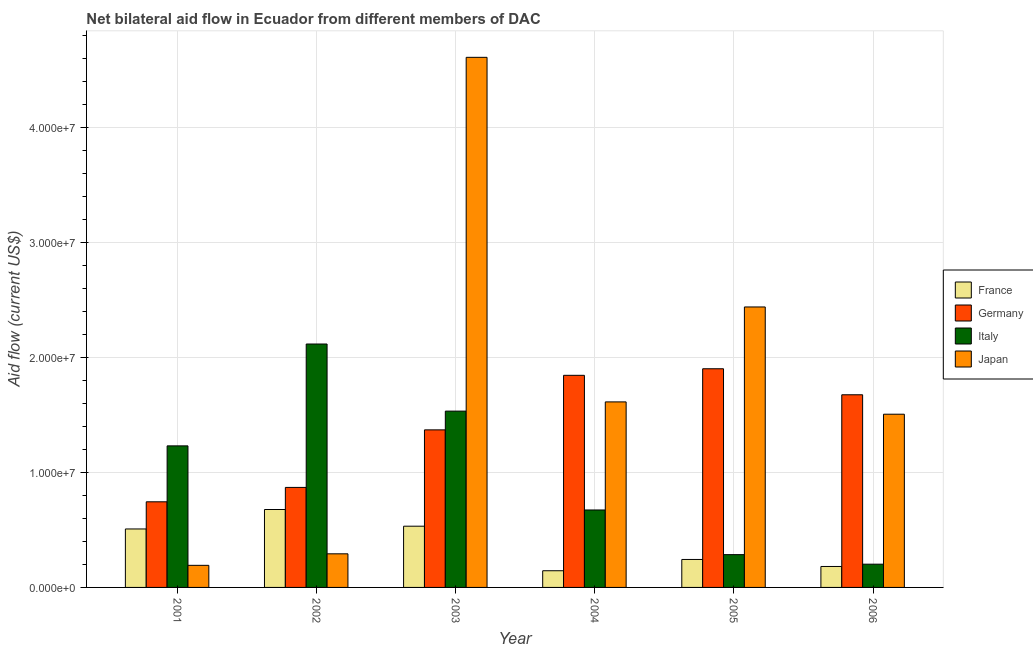How many different coloured bars are there?
Provide a succinct answer. 4. How many groups of bars are there?
Give a very brief answer. 6. Are the number of bars per tick equal to the number of legend labels?
Provide a succinct answer. Yes. Are the number of bars on each tick of the X-axis equal?
Provide a short and direct response. Yes. How many bars are there on the 3rd tick from the left?
Your answer should be compact. 4. How many bars are there on the 2nd tick from the right?
Make the answer very short. 4. What is the label of the 3rd group of bars from the left?
Make the answer very short. 2003. What is the amount of aid given by germany in 2005?
Your response must be concise. 1.90e+07. Across all years, what is the maximum amount of aid given by japan?
Provide a succinct answer. 4.61e+07. Across all years, what is the minimum amount of aid given by germany?
Provide a succinct answer. 7.44e+06. In which year was the amount of aid given by germany maximum?
Provide a short and direct response. 2005. What is the total amount of aid given by germany in the graph?
Offer a very short reply. 8.40e+07. What is the difference between the amount of aid given by france in 2005 and that in 2006?
Give a very brief answer. 6.10e+05. What is the difference between the amount of aid given by germany in 2004 and the amount of aid given by italy in 2006?
Provide a short and direct response. 1.69e+06. What is the average amount of aid given by japan per year?
Your response must be concise. 1.77e+07. In the year 2004, what is the difference between the amount of aid given by france and amount of aid given by italy?
Provide a succinct answer. 0. In how many years, is the amount of aid given by japan greater than 8000000 US$?
Give a very brief answer. 4. What is the ratio of the amount of aid given by germany in 2001 to that in 2005?
Your response must be concise. 0.39. Is the amount of aid given by japan in 2001 less than that in 2003?
Your response must be concise. Yes. Is the difference between the amount of aid given by germany in 2004 and 2006 greater than the difference between the amount of aid given by italy in 2004 and 2006?
Provide a succinct answer. No. What is the difference between the highest and the second highest amount of aid given by france?
Your answer should be compact. 1.45e+06. What is the difference between the highest and the lowest amount of aid given by italy?
Offer a very short reply. 1.91e+07. In how many years, is the amount of aid given by france greater than the average amount of aid given by france taken over all years?
Give a very brief answer. 3. What does the 1st bar from the right in 2001 represents?
Ensure brevity in your answer.  Japan. Is it the case that in every year, the sum of the amount of aid given by france and amount of aid given by germany is greater than the amount of aid given by italy?
Your response must be concise. No. How many bars are there?
Keep it short and to the point. 24. What is the difference between two consecutive major ticks on the Y-axis?
Give a very brief answer. 1.00e+07. Does the graph contain any zero values?
Your answer should be very brief. No. Does the graph contain grids?
Provide a succinct answer. Yes. How are the legend labels stacked?
Provide a succinct answer. Vertical. What is the title of the graph?
Your response must be concise. Net bilateral aid flow in Ecuador from different members of DAC. Does "PFC gas" appear as one of the legend labels in the graph?
Your answer should be compact. No. What is the label or title of the X-axis?
Give a very brief answer. Year. What is the Aid flow (current US$) of France in 2001?
Your answer should be very brief. 5.08e+06. What is the Aid flow (current US$) in Germany in 2001?
Give a very brief answer. 7.44e+06. What is the Aid flow (current US$) of Italy in 2001?
Offer a terse response. 1.23e+07. What is the Aid flow (current US$) in Japan in 2001?
Ensure brevity in your answer.  1.92e+06. What is the Aid flow (current US$) in France in 2002?
Provide a succinct answer. 6.77e+06. What is the Aid flow (current US$) of Germany in 2002?
Your answer should be very brief. 8.69e+06. What is the Aid flow (current US$) in Italy in 2002?
Make the answer very short. 2.12e+07. What is the Aid flow (current US$) of Japan in 2002?
Keep it short and to the point. 2.92e+06. What is the Aid flow (current US$) in France in 2003?
Ensure brevity in your answer.  5.32e+06. What is the Aid flow (current US$) of Germany in 2003?
Provide a succinct answer. 1.37e+07. What is the Aid flow (current US$) in Italy in 2003?
Provide a short and direct response. 1.53e+07. What is the Aid flow (current US$) of Japan in 2003?
Provide a short and direct response. 4.61e+07. What is the Aid flow (current US$) in France in 2004?
Give a very brief answer. 1.45e+06. What is the Aid flow (current US$) in Germany in 2004?
Make the answer very short. 1.84e+07. What is the Aid flow (current US$) in Italy in 2004?
Provide a short and direct response. 6.73e+06. What is the Aid flow (current US$) in Japan in 2004?
Give a very brief answer. 1.61e+07. What is the Aid flow (current US$) in France in 2005?
Make the answer very short. 2.43e+06. What is the Aid flow (current US$) in Germany in 2005?
Ensure brevity in your answer.  1.90e+07. What is the Aid flow (current US$) of Italy in 2005?
Offer a very short reply. 2.85e+06. What is the Aid flow (current US$) of Japan in 2005?
Ensure brevity in your answer.  2.44e+07. What is the Aid flow (current US$) in France in 2006?
Provide a succinct answer. 1.82e+06. What is the Aid flow (current US$) in Germany in 2006?
Give a very brief answer. 1.67e+07. What is the Aid flow (current US$) of Italy in 2006?
Your response must be concise. 2.02e+06. What is the Aid flow (current US$) in Japan in 2006?
Provide a succinct answer. 1.50e+07. Across all years, what is the maximum Aid flow (current US$) of France?
Provide a succinct answer. 6.77e+06. Across all years, what is the maximum Aid flow (current US$) in Germany?
Offer a terse response. 1.90e+07. Across all years, what is the maximum Aid flow (current US$) in Italy?
Give a very brief answer. 2.12e+07. Across all years, what is the maximum Aid flow (current US$) of Japan?
Keep it short and to the point. 4.61e+07. Across all years, what is the minimum Aid flow (current US$) in France?
Your response must be concise. 1.45e+06. Across all years, what is the minimum Aid flow (current US$) in Germany?
Offer a terse response. 7.44e+06. Across all years, what is the minimum Aid flow (current US$) of Italy?
Give a very brief answer. 2.02e+06. Across all years, what is the minimum Aid flow (current US$) of Japan?
Provide a succinct answer. 1.92e+06. What is the total Aid flow (current US$) in France in the graph?
Give a very brief answer. 2.29e+07. What is the total Aid flow (current US$) of Germany in the graph?
Make the answer very short. 8.40e+07. What is the total Aid flow (current US$) of Italy in the graph?
Offer a terse response. 6.04e+07. What is the total Aid flow (current US$) in Japan in the graph?
Ensure brevity in your answer.  1.06e+08. What is the difference between the Aid flow (current US$) of France in 2001 and that in 2002?
Your response must be concise. -1.69e+06. What is the difference between the Aid flow (current US$) of Germany in 2001 and that in 2002?
Give a very brief answer. -1.25e+06. What is the difference between the Aid flow (current US$) in Italy in 2001 and that in 2002?
Ensure brevity in your answer.  -8.85e+06. What is the difference between the Aid flow (current US$) of Germany in 2001 and that in 2003?
Your response must be concise. -6.25e+06. What is the difference between the Aid flow (current US$) of Italy in 2001 and that in 2003?
Your answer should be very brief. -3.02e+06. What is the difference between the Aid flow (current US$) of Japan in 2001 and that in 2003?
Your answer should be very brief. -4.41e+07. What is the difference between the Aid flow (current US$) in France in 2001 and that in 2004?
Keep it short and to the point. 3.63e+06. What is the difference between the Aid flow (current US$) of Germany in 2001 and that in 2004?
Provide a short and direct response. -1.10e+07. What is the difference between the Aid flow (current US$) of Italy in 2001 and that in 2004?
Offer a terse response. 5.57e+06. What is the difference between the Aid flow (current US$) of Japan in 2001 and that in 2004?
Your answer should be compact. -1.42e+07. What is the difference between the Aid flow (current US$) of France in 2001 and that in 2005?
Offer a terse response. 2.65e+06. What is the difference between the Aid flow (current US$) in Germany in 2001 and that in 2005?
Your response must be concise. -1.16e+07. What is the difference between the Aid flow (current US$) in Italy in 2001 and that in 2005?
Keep it short and to the point. 9.45e+06. What is the difference between the Aid flow (current US$) of Japan in 2001 and that in 2005?
Give a very brief answer. -2.24e+07. What is the difference between the Aid flow (current US$) of France in 2001 and that in 2006?
Keep it short and to the point. 3.26e+06. What is the difference between the Aid flow (current US$) in Germany in 2001 and that in 2006?
Make the answer very short. -9.30e+06. What is the difference between the Aid flow (current US$) of Italy in 2001 and that in 2006?
Give a very brief answer. 1.03e+07. What is the difference between the Aid flow (current US$) in Japan in 2001 and that in 2006?
Keep it short and to the point. -1.31e+07. What is the difference between the Aid flow (current US$) in France in 2002 and that in 2003?
Offer a very short reply. 1.45e+06. What is the difference between the Aid flow (current US$) in Germany in 2002 and that in 2003?
Your answer should be compact. -5.00e+06. What is the difference between the Aid flow (current US$) of Italy in 2002 and that in 2003?
Keep it short and to the point. 5.83e+06. What is the difference between the Aid flow (current US$) of Japan in 2002 and that in 2003?
Provide a short and direct response. -4.31e+07. What is the difference between the Aid flow (current US$) in France in 2002 and that in 2004?
Make the answer very short. 5.32e+06. What is the difference between the Aid flow (current US$) of Germany in 2002 and that in 2004?
Offer a very short reply. -9.74e+06. What is the difference between the Aid flow (current US$) in Italy in 2002 and that in 2004?
Your response must be concise. 1.44e+07. What is the difference between the Aid flow (current US$) of Japan in 2002 and that in 2004?
Offer a terse response. -1.32e+07. What is the difference between the Aid flow (current US$) in France in 2002 and that in 2005?
Give a very brief answer. 4.34e+06. What is the difference between the Aid flow (current US$) in Germany in 2002 and that in 2005?
Your answer should be very brief. -1.03e+07. What is the difference between the Aid flow (current US$) in Italy in 2002 and that in 2005?
Your response must be concise. 1.83e+07. What is the difference between the Aid flow (current US$) in Japan in 2002 and that in 2005?
Your answer should be very brief. -2.14e+07. What is the difference between the Aid flow (current US$) in France in 2002 and that in 2006?
Your answer should be very brief. 4.95e+06. What is the difference between the Aid flow (current US$) of Germany in 2002 and that in 2006?
Your answer should be very brief. -8.05e+06. What is the difference between the Aid flow (current US$) in Italy in 2002 and that in 2006?
Your answer should be very brief. 1.91e+07. What is the difference between the Aid flow (current US$) of Japan in 2002 and that in 2006?
Offer a very short reply. -1.21e+07. What is the difference between the Aid flow (current US$) of France in 2003 and that in 2004?
Provide a succinct answer. 3.87e+06. What is the difference between the Aid flow (current US$) in Germany in 2003 and that in 2004?
Your answer should be compact. -4.74e+06. What is the difference between the Aid flow (current US$) in Italy in 2003 and that in 2004?
Ensure brevity in your answer.  8.59e+06. What is the difference between the Aid flow (current US$) of Japan in 2003 and that in 2004?
Provide a short and direct response. 2.99e+07. What is the difference between the Aid flow (current US$) in France in 2003 and that in 2005?
Provide a succinct answer. 2.89e+06. What is the difference between the Aid flow (current US$) in Germany in 2003 and that in 2005?
Offer a very short reply. -5.31e+06. What is the difference between the Aid flow (current US$) in Italy in 2003 and that in 2005?
Your answer should be compact. 1.25e+07. What is the difference between the Aid flow (current US$) of Japan in 2003 and that in 2005?
Keep it short and to the point. 2.17e+07. What is the difference between the Aid flow (current US$) of France in 2003 and that in 2006?
Your answer should be compact. 3.50e+06. What is the difference between the Aid flow (current US$) of Germany in 2003 and that in 2006?
Make the answer very short. -3.05e+06. What is the difference between the Aid flow (current US$) in Italy in 2003 and that in 2006?
Provide a succinct answer. 1.33e+07. What is the difference between the Aid flow (current US$) of Japan in 2003 and that in 2006?
Give a very brief answer. 3.10e+07. What is the difference between the Aid flow (current US$) in France in 2004 and that in 2005?
Offer a terse response. -9.80e+05. What is the difference between the Aid flow (current US$) of Germany in 2004 and that in 2005?
Provide a succinct answer. -5.70e+05. What is the difference between the Aid flow (current US$) in Italy in 2004 and that in 2005?
Provide a short and direct response. 3.88e+06. What is the difference between the Aid flow (current US$) of Japan in 2004 and that in 2005?
Ensure brevity in your answer.  -8.25e+06. What is the difference between the Aid flow (current US$) in France in 2004 and that in 2006?
Keep it short and to the point. -3.70e+05. What is the difference between the Aid flow (current US$) of Germany in 2004 and that in 2006?
Ensure brevity in your answer.  1.69e+06. What is the difference between the Aid flow (current US$) in Italy in 2004 and that in 2006?
Provide a short and direct response. 4.71e+06. What is the difference between the Aid flow (current US$) of Japan in 2004 and that in 2006?
Give a very brief answer. 1.07e+06. What is the difference between the Aid flow (current US$) in France in 2005 and that in 2006?
Keep it short and to the point. 6.10e+05. What is the difference between the Aid flow (current US$) in Germany in 2005 and that in 2006?
Your answer should be compact. 2.26e+06. What is the difference between the Aid flow (current US$) of Italy in 2005 and that in 2006?
Make the answer very short. 8.30e+05. What is the difference between the Aid flow (current US$) in Japan in 2005 and that in 2006?
Make the answer very short. 9.32e+06. What is the difference between the Aid flow (current US$) of France in 2001 and the Aid flow (current US$) of Germany in 2002?
Ensure brevity in your answer.  -3.61e+06. What is the difference between the Aid flow (current US$) of France in 2001 and the Aid flow (current US$) of Italy in 2002?
Provide a succinct answer. -1.61e+07. What is the difference between the Aid flow (current US$) of France in 2001 and the Aid flow (current US$) of Japan in 2002?
Your answer should be very brief. 2.16e+06. What is the difference between the Aid flow (current US$) in Germany in 2001 and the Aid flow (current US$) in Italy in 2002?
Make the answer very short. -1.37e+07. What is the difference between the Aid flow (current US$) in Germany in 2001 and the Aid flow (current US$) in Japan in 2002?
Your answer should be very brief. 4.52e+06. What is the difference between the Aid flow (current US$) of Italy in 2001 and the Aid flow (current US$) of Japan in 2002?
Offer a very short reply. 9.38e+06. What is the difference between the Aid flow (current US$) of France in 2001 and the Aid flow (current US$) of Germany in 2003?
Keep it short and to the point. -8.61e+06. What is the difference between the Aid flow (current US$) of France in 2001 and the Aid flow (current US$) of Italy in 2003?
Make the answer very short. -1.02e+07. What is the difference between the Aid flow (current US$) of France in 2001 and the Aid flow (current US$) of Japan in 2003?
Provide a succinct answer. -4.10e+07. What is the difference between the Aid flow (current US$) in Germany in 2001 and the Aid flow (current US$) in Italy in 2003?
Keep it short and to the point. -7.88e+06. What is the difference between the Aid flow (current US$) of Germany in 2001 and the Aid flow (current US$) of Japan in 2003?
Keep it short and to the point. -3.86e+07. What is the difference between the Aid flow (current US$) of Italy in 2001 and the Aid flow (current US$) of Japan in 2003?
Provide a short and direct response. -3.38e+07. What is the difference between the Aid flow (current US$) of France in 2001 and the Aid flow (current US$) of Germany in 2004?
Your response must be concise. -1.34e+07. What is the difference between the Aid flow (current US$) in France in 2001 and the Aid flow (current US$) in Italy in 2004?
Give a very brief answer. -1.65e+06. What is the difference between the Aid flow (current US$) of France in 2001 and the Aid flow (current US$) of Japan in 2004?
Make the answer very short. -1.10e+07. What is the difference between the Aid flow (current US$) in Germany in 2001 and the Aid flow (current US$) in Italy in 2004?
Your response must be concise. 7.10e+05. What is the difference between the Aid flow (current US$) of Germany in 2001 and the Aid flow (current US$) of Japan in 2004?
Keep it short and to the point. -8.68e+06. What is the difference between the Aid flow (current US$) in Italy in 2001 and the Aid flow (current US$) in Japan in 2004?
Give a very brief answer. -3.82e+06. What is the difference between the Aid flow (current US$) of France in 2001 and the Aid flow (current US$) of Germany in 2005?
Offer a terse response. -1.39e+07. What is the difference between the Aid flow (current US$) in France in 2001 and the Aid flow (current US$) in Italy in 2005?
Your response must be concise. 2.23e+06. What is the difference between the Aid flow (current US$) in France in 2001 and the Aid flow (current US$) in Japan in 2005?
Your answer should be compact. -1.93e+07. What is the difference between the Aid flow (current US$) of Germany in 2001 and the Aid flow (current US$) of Italy in 2005?
Give a very brief answer. 4.59e+06. What is the difference between the Aid flow (current US$) of Germany in 2001 and the Aid flow (current US$) of Japan in 2005?
Offer a terse response. -1.69e+07. What is the difference between the Aid flow (current US$) of Italy in 2001 and the Aid flow (current US$) of Japan in 2005?
Provide a succinct answer. -1.21e+07. What is the difference between the Aid flow (current US$) in France in 2001 and the Aid flow (current US$) in Germany in 2006?
Your answer should be very brief. -1.17e+07. What is the difference between the Aid flow (current US$) of France in 2001 and the Aid flow (current US$) of Italy in 2006?
Provide a short and direct response. 3.06e+06. What is the difference between the Aid flow (current US$) in France in 2001 and the Aid flow (current US$) in Japan in 2006?
Make the answer very short. -9.97e+06. What is the difference between the Aid flow (current US$) of Germany in 2001 and the Aid flow (current US$) of Italy in 2006?
Your answer should be very brief. 5.42e+06. What is the difference between the Aid flow (current US$) in Germany in 2001 and the Aid flow (current US$) in Japan in 2006?
Keep it short and to the point. -7.61e+06. What is the difference between the Aid flow (current US$) of Italy in 2001 and the Aid flow (current US$) of Japan in 2006?
Ensure brevity in your answer.  -2.75e+06. What is the difference between the Aid flow (current US$) of France in 2002 and the Aid flow (current US$) of Germany in 2003?
Offer a very short reply. -6.92e+06. What is the difference between the Aid flow (current US$) of France in 2002 and the Aid flow (current US$) of Italy in 2003?
Offer a terse response. -8.55e+06. What is the difference between the Aid flow (current US$) of France in 2002 and the Aid flow (current US$) of Japan in 2003?
Give a very brief answer. -3.93e+07. What is the difference between the Aid flow (current US$) in Germany in 2002 and the Aid flow (current US$) in Italy in 2003?
Your answer should be compact. -6.63e+06. What is the difference between the Aid flow (current US$) in Germany in 2002 and the Aid flow (current US$) in Japan in 2003?
Ensure brevity in your answer.  -3.74e+07. What is the difference between the Aid flow (current US$) of Italy in 2002 and the Aid flow (current US$) of Japan in 2003?
Make the answer very short. -2.49e+07. What is the difference between the Aid flow (current US$) of France in 2002 and the Aid flow (current US$) of Germany in 2004?
Your response must be concise. -1.17e+07. What is the difference between the Aid flow (current US$) of France in 2002 and the Aid flow (current US$) of Japan in 2004?
Offer a very short reply. -9.35e+06. What is the difference between the Aid flow (current US$) in Germany in 2002 and the Aid flow (current US$) in Italy in 2004?
Make the answer very short. 1.96e+06. What is the difference between the Aid flow (current US$) in Germany in 2002 and the Aid flow (current US$) in Japan in 2004?
Your answer should be compact. -7.43e+06. What is the difference between the Aid flow (current US$) in Italy in 2002 and the Aid flow (current US$) in Japan in 2004?
Offer a terse response. 5.03e+06. What is the difference between the Aid flow (current US$) in France in 2002 and the Aid flow (current US$) in Germany in 2005?
Offer a terse response. -1.22e+07. What is the difference between the Aid flow (current US$) of France in 2002 and the Aid flow (current US$) of Italy in 2005?
Ensure brevity in your answer.  3.92e+06. What is the difference between the Aid flow (current US$) of France in 2002 and the Aid flow (current US$) of Japan in 2005?
Your answer should be very brief. -1.76e+07. What is the difference between the Aid flow (current US$) in Germany in 2002 and the Aid flow (current US$) in Italy in 2005?
Provide a short and direct response. 5.84e+06. What is the difference between the Aid flow (current US$) in Germany in 2002 and the Aid flow (current US$) in Japan in 2005?
Provide a short and direct response. -1.57e+07. What is the difference between the Aid flow (current US$) of Italy in 2002 and the Aid flow (current US$) of Japan in 2005?
Your response must be concise. -3.22e+06. What is the difference between the Aid flow (current US$) in France in 2002 and the Aid flow (current US$) in Germany in 2006?
Your answer should be very brief. -9.97e+06. What is the difference between the Aid flow (current US$) in France in 2002 and the Aid flow (current US$) in Italy in 2006?
Your answer should be compact. 4.75e+06. What is the difference between the Aid flow (current US$) of France in 2002 and the Aid flow (current US$) of Japan in 2006?
Provide a succinct answer. -8.28e+06. What is the difference between the Aid flow (current US$) of Germany in 2002 and the Aid flow (current US$) of Italy in 2006?
Offer a very short reply. 6.67e+06. What is the difference between the Aid flow (current US$) in Germany in 2002 and the Aid flow (current US$) in Japan in 2006?
Your answer should be very brief. -6.36e+06. What is the difference between the Aid flow (current US$) in Italy in 2002 and the Aid flow (current US$) in Japan in 2006?
Your answer should be compact. 6.10e+06. What is the difference between the Aid flow (current US$) of France in 2003 and the Aid flow (current US$) of Germany in 2004?
Your response must be concise. -1.31e+07. What is the difference between the Aid flow (current US$) of France in 2003 and the Aid flow (current US$) of Italy in 2004?
Offer a very short reply. -1.41e+06. What is the difference between the Aid flow (current US$) in France in 2003 and the Aid flow (current US$) in Japan in 2004?
Offer a very short reply. -1.08e+07. What is the difference between the Aid flow (current US$) in Germany in 2003 and the Aid flow (current US$) in Italy in 2004?
Your answer should be compact. 6.96e+06. What is the difference between the Aid flow (current US$) of Germany in 2003 and the Aid flow (current US$) of Japan in 2004?
Offer a terse response. -2.43e+06. What is the difference between the Aid flow (current US$) of Italy in 2003 and the Aid flow (current US$) of Japan in 2004?
Your answer should be compact. -8.00e+05. What is the difference between the Aid flow (current US$) in France in 2003 and the Aid flow (current US$) in Germany in 2005?
Make the answer very short. -1.37e+07. What is the difference between the Aid flow (current US$) in France in 2003 and the Aid flow (current US$) in Italy in 2005?
Provide a short and direct response. 2.47e+06. What is the difference between the Aid flow (current US$) in France in 2003 and the Aid flow (current US$) in Japan in 2005?
Your response must be concise. -1.90e+07. What is the difference between the Aid flow (current US$) of Germany in 2003 and the Aid flow (current US$) of Italy in 2005?
Offer a terse response. 1.08e+07. What is the difference between the Aid flow (current US$) in Germany in 2003 and the Aid flow (current US$) in Japan in 2005?
Your answer should be compact. -1.07e+07. What is the difference between the Aid flow (current US$) in Italy in 2003 and the Aid flow (current US$) in Japan in 2005?
Make the answer very short. -9.05e+06. What is the difference between the Aid flow (current US$) of France in 2003 and the Aid flow (current US$) of Germany in 2006?
Your answer should be compact. -1.14e+07. What is the difference between the Aid flow (current US$) in France in 2003 and the Aid flow (current US$) in Italy in 2006?
Give a very brief answer. 3.30e+06. What is the difference between the Aid flow (current US$) of France in 2003 and the Aid flow (current US$) of Japan in 2006?
Make the answer very short. -9.73e+06. What is the difference between the Aid flow (current US$) in Germany in 2003 and the Aid flow (current US$) in Italy in 2006?
Offer a terse response. 1.17e+07. What is the difference between the Aid flow (current US$) in Germany in 2003 and the Aid flow (current US$) in Japan in 2006?
Your answer should be very brief. -1.36e+06. What is the difference between the Aid flow (current US$) in France in 2004 and the Aid flow (current US$) in Germany in 2005?
Offer a very short reply. -1.76e+07. What is the difference between the Aid flow (current US$) of France in 2004 and the Aid flow (current US$) of Italy in 2005?
Give a very brief answer. -1.40e+06. What is the difference between the Aid flow (current US$) in France in 2004 and the Aid flow (current US$) in Japan in 2005?
Your answer should be compact. -2.29e+07. What is the difference between the Aid flow (current US$) in Germany in 2004 and the Aid flow (current US$) in Italy in 2005?
Your answer should be very brief. 1.56e+07. What is the difference between the Aid flow (current US$) of Germany in 2004 and the Aid flow (current US$) of Japan in 2005?
Make the answer very short. -5.94e+06. What is the difference between the Aid flow (current US$) in Italy in 2004 and the Aid flow (current US$) in Japan in 2005?
Provide a succinct answer. -1.76e+07. What is the difference between the Aid flow (current US$) in France in 2004 and the Aid flow (current US$) in Germany in 2006?
Offer a terse response. -1.53e+07. What is the difference between the Aid flow (current US$) of France in 2004 and the Aid flow (current US$) of Italy in 2006?
Give a very brief answer. -5.70e+05. What is the difference between the Aid flow (current US$) of France in 2004 and the Aid flow (current US$) of Japan in 2006?
Keep it short and to the point. -1.36e+07. What is the difference between the Aid flow (current US$) in Germany in 2004 and the Aid flow (current US$) in Italy in 2006?
Keep it short and to the point. 1.64e+07. What is the difference between the Aid flow (current US$) of Germany in 2004 and the Aid flow (current US$) of Japan in 2006?
Your response must be concise. 3.38e+06. What is the difference between the Aid flow (current US$) in Italy in 2004 and the Aid flow (current US$) in Japan in 2006?
Give a very brief answer. -8.32e+06. What is the difference between the Aid flow (current US$) in France in 2005 and the Aid flow (current US$) in Germany in 2006?
Your response must be concise. -1.43e+07. What is the difference between the Aid flow (current US$) in France in 2005 and the Aid flow (current US$) in Japan in 2006?
Make the answer very short. -1.26e+07. What is the difference between the Aid flow (current US$) of Germany in 2005 and the Aid flow (current US$) of Italy in 2006?
Your response must be concise. 1.70e+07. What is the difference between the Aid flow (current US$) of Germany in 2005 and the Aid flow (current US$) of Japan in 2006?
Your answer should be very brief. 3.95e+06. What is the difference between the Aid flow (current US$) of Italy in 2005 and the Aid flow (current US$) of Japan in 2006?
Offer a very short reply. -1.22e+07. What is the average Aid flow (current US$) in France per year?
Keep it short and to the point. 3.81e+06. What is the average Aid flow (current US$) in Germany per year?
Provide a succinct answer. 1.40e+07. What is the average Aid flow (current US$) in Italy per year?
Keep it short and to the point. 1.01e+07. What is the average Aid flow (current US$) of Japan per year?
Keep it short and to the point. 1.77e+07. In the year 2001, what is the difference between the Aid flow (current US$) in France and Aid flow (current US$) in Germany?
Your answer should be compact. -2.36e+06. In the year 2001, what is the difference between the Aid flow (current US$) of France and Aid flow (current US$) of Italy?
Ensure brevity in your answer.  -7.22e+06. In the year 2001, what is the difference between the Aid flow (current US$) in France and Aid flow (current US$) in Japan?
Offer a terse response. 3.16e+06. In the year 2001, what is the difference between the Aid flow (current US$) in Germany and Aid flow (current US$) in Italy?
Provide a succinct answer. -4.86e+06. In the year 2001, what is the difference between the Aid flow (current US$) of Germany and Aid flow (current US$) of Japan?
Your response must be concise. 5.52e+06. In the year 2001, what is the difference between the Aid flow (current US$) in Italy and Aid flow (current US$) in Japan?
Make the answer very short. 1.04e+07. In the year 2002, what is the difference between the Aid flow (current US$) in France and Aid flow (current US$) in Germany?
Your answer should be very brief. -1.92e+06. In the year 2002, what is the difference between the Aid flow (current US$) in France and Aid flow (current US$) in Italy?
Provide a short and direct response. -1.44e+07. In the year 2002, what is the difference between the Aid flow (current US$) of France and Aid flow (current US$) of Japan?
Give a very brief answer. 3.85e+06. In the year 2002, what is the difference between the Aid flow (current US$) in Germany and Aid flow (current US$) in Italy?
Your answer should be very brief. -1.25e+07. In the year 2002, what is the difference between the Aid flow (current US$) of Germany and Aid flow (current US$) of Japan?
Give a very brief answer. 5.77e+06. In the year 2002, what is the difference between the Aid flow (current US$) in Italy and Aid flow (current US$) in Japan?
Your response must be concise. 1.82e+07. In the year 2003, what is the difference between the Aid flow (current US$) of France and Aid flow (current US$) of Germany?
Provide a succinct answer. -8.37e+06. In the year 2003, what is the difference between the Aid flow (current US$) in France and Aid flow (current US$) in Italy?
Give a very brief answer. -1.00e+07. In the year 2003, what is the difference between the Aid flow (current US$) of France and Aid flow (current US$) of Japan?
Give a very brief answer. -4.07e+07. In the year 2003, what is the difference between the Aid flow (current US$) in Germany and Aid flow (current US$) in Italy?
Your answer should be very brief. -1.63e+06. In the year 2003, what is the difference between the Aid flow (current US$) in Germany and Aid flow (current US$) in Japan?
Provide a short and direct response. -3.24e+07. In the year 2003, what is the difference between the Aid flow (current US$) in Italy and Aid flow (current US$) in Japan?
Your response must be concise. -3.07e+07. In the year 2004, what is the difference between the Aid flow (current US$) in France and Aid flow (current US$) in Germany?
Ensure brevity in your answer.  -1.70e+07. In the year 2004, what is the difference between the Aid flow (current US$) in France and Aid flow (current US$) in Italy?
Offer a very short reply. -5.28e+06. In the year 2004, what is the difference between the Aid flow (current US$) in France and Aid flow (current US$) in Japan?
Make the answer very short. -1.47e+07. In the year 2004, what is the difference between the Aid flow (current US$) in Germany and Aid flow (current US$) in Italy?
Provide a succinct answer. 1.17e+07. In the year 2004, what is the difference between the Aid flow (current US$) in Germany and Aid flow (current US$) in Japan?
Make the answer very short. 2.31e+06. In the year 2004, what is the difference between the Aid flow (current US$) in Italy and Aid flow (current US$) in Japan?
Provide a succinct answer. -9.39e+06. In the year 2005, what is the difference between the Aid flow (current US$) in France and Aid flow (current US$) in Germany?
Your response must be concise. -1.66e+07. In the year 2005, what is the difference between the Aid flow (current US$) of France and Aid flow (current US$) of Italy?
Your answer should be compact. -4.20e+05. In the year 2005, what is the difference between the Aid flow (current US$) of France and Aid flow (current US$) of Japan?
Your answer should be very brief. -2.19e+07. In the year 2005, what is the difference between the Aid flow (current US$) of Germany and Aid flow (current US$) of Italy?
Give a very brief answer. 1.62e+07. In the year 2005, what is the difference between the Aid flow (current US$) in Germany and Aid flow (current US$) in Japan?
Offer a terse response. -5.37e+06. In the year 2005, what is the difference between the Aid flow (current US$) in Italy and Aid flow (current US$) in Japan?
Your response must be concise. -2.15e+07. In the year 2006, what is the difference between the Aid flow (current US$) of France and Aid flow (current US$) of Germany?
Your answer should be compact. -1.49e+07. In the year 2006, what is the difference between the Aid flow (current US$) in France and Aid flow (current US$) in Japan?
Offer a very short reply. -1.32e+07. In the year 2006, what is the difference between the Aid flow (current US$) of Germany and Aid flow (current US$) of Italy?
Give a very brief answer. 1.47e+07. In the year 2006, what is the difference between the Aid flow (current US$) in Germany and Aid flow (current US$) in Japan?
Ensure brevity in your answer.  1.69e+06. In the year 2006, what is the difference between the Aid flow (current US$) of Italy and Aid flow (current US$) of Japan?
Provide a short and direct response. -1.30e+07. What is the ratio of the Aid flow (current US$) in France in 2001 to that in 2002?
Provide a short and direct response. 0.75. What is the ratio of the Aid flow (current US$) in Germany in 2001 to that in 2002?
Offer a terse response. 0.86. What is the ratio of the Aid flow (current US$) of Italy in 2001 to that in 2002?
Your response must be concise. 0.58. What is the ratio of the Aid flow (current US$) in Japan in 2001 to that in 2002?
Your response must be concise. 0.66. What is the ratio of the Aid flow (current US$) in France in 2001 to that in 2003?
Offer a very short reply. 0.95. What is the ratio of the Aid flow (current US$) in Germany in 2001 to that in 2003?
Keep it short and to the point. 0.54. What is the ratio of the Aid flow (current US$) of Italy in 2001 to that in 2003?
Keep it short and to the point. 0.8. What is the ratio of the Aid flow (current US$) in Japan in 2001 to that in 2003?
Your answer should be very brief. 0.04. What is the ratio of the Aid flow (current US$) of France in 2001 to that in 2004?
Keep it short and to the point. 3.5. What is the ratio of the Aid flow (current US$) in Germany in 2001 to that in 2004?
Keep it short and to the point. 0.4. What is the ratio of the Aid flow (current US$) of Italy in 2001 to that in 2004?
Your answer should be compact. 1.83. What is the ratio of the Aid flow (current US$) of Japan in 2001 to that in 2004?
Your answer should be compact. 0.12. What is the ratio of the Aid flow (current US$) in France in 2001 to that in 2005?
Offer a terse response. 2.09. What is the ratio of the Aid flow (current US$) in Germany in 2001 to that in 2005?
Provide a short and direct response. 0.39. What is the ratio of the Aid flow (current US$) of Italy in 2001 to that in 2005?
Provide a short and direct response. 4.32. What is the ratio of the Aid flow (current US$) in Japan in 2001 to that in 2005?
Provide a succinct answer. 0.08. What is the ratio of the Aid flow (current US$) in France in 2001 to that in 2006?
Ensure brevity in your answer.  2.79. What is the ratio of the Aid flow (current US$) of Germany in 2001 to that in 2006?
Your answer should be compact. 0.44. What is the ratio of the Aid flow (current US$) of Italy in 2001 to that in 2006?
Ensure brevity in your answer.  6.09. What is the ratio of the Aid flow (current US$) of Japan in 2001 to that in 2006?
Offer a very short reply. 0.13. What is the ratio of the Aid flow (current US$) in France in 2002 to that in 2003?
Offer a very short reply. 1.27. What is the ratio of the Aid flow (current US$) of Germany in 2002 to that in 2003?
Offer a terse response. 0.63. What is the ratio of the Aid flow (current US$) of Italy in 2002 to that in 2003?
Make the answer very short. 1.38. What is the ratio of the Aid flow (current US$) in Japan in 2002 to that in 2003?
Your answer should be compact. 0.06. What is the ratio of the Aid flow (current US$) of France in 2002 to that in 2004?
Your answer should be compact. 4.67. What is the ratio of the Aid flow (current US$) of Germany in 2002 to that in 2004?
Your answer should be very brief. 0.47. What is the ratio of the Aid flow (current US$) of Italy in 2002 to that in 2004?
Your answer should be very brief. 3.14. What is the ratio of the Aid flow (current US$) in Japan in 2002 to that in 2004?
Ensure brevity in your answer.  0.18. What is the ratio of the Aid flow (current US$) in France in 2002 to that in 2005?
Offer a terse response. 2.79. What is the ratio of the Aid flow (current US$) of Germany in 2002 to that in 2005?
Your answer should be very brief. 0.46. What is the ratio of the Aid flow (current US$) in Italy in 2002 to that in 2005?
Your answer should be compact. 7.42. What is the ratio of the Aid flow (current US$) in Japan in 2002 to that in 2005?
Your response must be concise. 0.12. What is the ratio of the Aid flow (current US$) in France in 2002 to that in 2006?
Your answer should be very brief. 3.72. What is the ratio of the Aid flow (current US$) in Germany in 2002 to that in 2006?
Keep it short and to the point. 0.52. What is the ratio of the Aid flow (current US$) of Italy in 2002 to that in 2006?
Provide a succinct answer. 10.47. What is the ratio of the Aid flow (current US$) of Japan in 2002 to that in 2006?
Your answer should be very brief. 0.19. What is the ratio of the Aid flow (current US$) of France in 2003 to that in 2004?
Ensure brevity in your answer.  3.67. What is the ratio of the Aid flow (current US$) of Germany in 2003 to that in 2004?
Keep it short and to the point. 0.74. What is the ratio of the Aid flow (current US$) of Italy in 2003 to that in 2004?
Provide a short and direct response. 2.28. What is the ratio of the Aid flow (current US$) of Japan in 2003 to that in 2004?
Offer a terse response. 2.86. What is the ratio of the Aid flow (current US$) in France in 2003 to that in 2005?
Offer a terse response. 2.19. What is the ratio of the Aid flow (current US$) of Germany in 2003 to that in 2005?
Provide a short and direct response. 0.72. What is the ratio of the Aid flow (current US$) in Italy in 2003 to that in 2005?
Offer a terse response. 5.38. What is the ratio of the Aid flow (current US$) in Japan in 2003 to that in 2005?
Provide a succinct answer. 1.89. What is the ratio of the Aid flow (current US$) in France in 2003 to that in 2006?
Your response must be concise. 2.92. What is the ratio of the Aid flow (current US$) of Germany in 2003 to that in 2006?
Your answer should be very brief. 0.82. What is the ratio of the Aid flow (current US$) in Italy in 2003 to that in 2006?
Keep it short and to the point. 7.58. What is the ratio of the Aid flow (current US$) of Japan in 2003 to that in 2006?
Provide a short and direct response. 3.06. What is the ratio of the Aid flow (current US$) of France in 2004 to that in 2005?
Offer a terse response. 0.6. What is the ratio of the Aid flow (current US$) of Germany in 2004 to that in 2005?
Your answer should be compact. 0.97. What is the ratio of the Aid flow (current US$) in Italy in 2004 to that in 2005?
Provide a succinct answer. 2.36. What is the ratio of the Aid flow (current US$) in Japan in 2004 to that in 2005?
Your answer should be very brief. 0.66. What is the ratio of the Aid flow (current US$) of France in 2004 to that in 2006?
Your answer should be very brief. 0.8. What is the ratio of the Aid flow (current US$) in Germany in 2004 to that in 2006?
Your answer should be compact. 1.1. What is the ratio of the Aid flow (current US$) of Italy in 2004 to that in 2006?
Provide a short and direct response. 3.33. What is the ratio of the Aid flow (current US$) of Japan in 2004 to that in 2006?
Your answer should be very brief. 1.07. What is the ratio of the Aid flow (current US$) in France in 2005 to that in 2006?
Your response must be concise. 1.34. What is the ratio of the Aid flow (current US$) in Germany in 2005 to that in 2006?
Offer a very short reply. 1.14. What is the ratio of the Aid flow (current US$) in Italy in 2005 to that in 2006?
Offer a very short reply. 1.41. What is the ratio of the Aid flow (current US$) of Japan in 2005 to that in 2006?
Your response must be concise. 1.62. What is the difference between the highest and the second highest Aid flow (current US$) of France?
Make the answer very short. 1.45e+06. What is the difference between the highest and the second highest Aid flow (current US$) of Germany?
Give a very brief answer. 5.70e+05. What is the difference between the highest and the second highest Aid flow (current US$) of Italy?
Ensure brevity in your answer.  5.83e+06. What is the difference between the highest and the second highest Aid flow (current US$) in Japan?
Provide a short and direct response. 2.17e+07. What is the difference between the highest and the lowest Aid flow (current US$) of France?
Ensure brevity in your answer.  5.32e+06. What is the difference between the highest and the lowest Aid flow (current US$) of Germany?
Your response must be concise. 1.16e+07. What is the difference between the highest and the lowest Aid flow (current US$) in Italy?
Your response must be concise. 1.91e+07. What is the difference between the highest and the lowest Aid flow (current US$) in Japan?
Your response must be concise. 4.41e+07. 